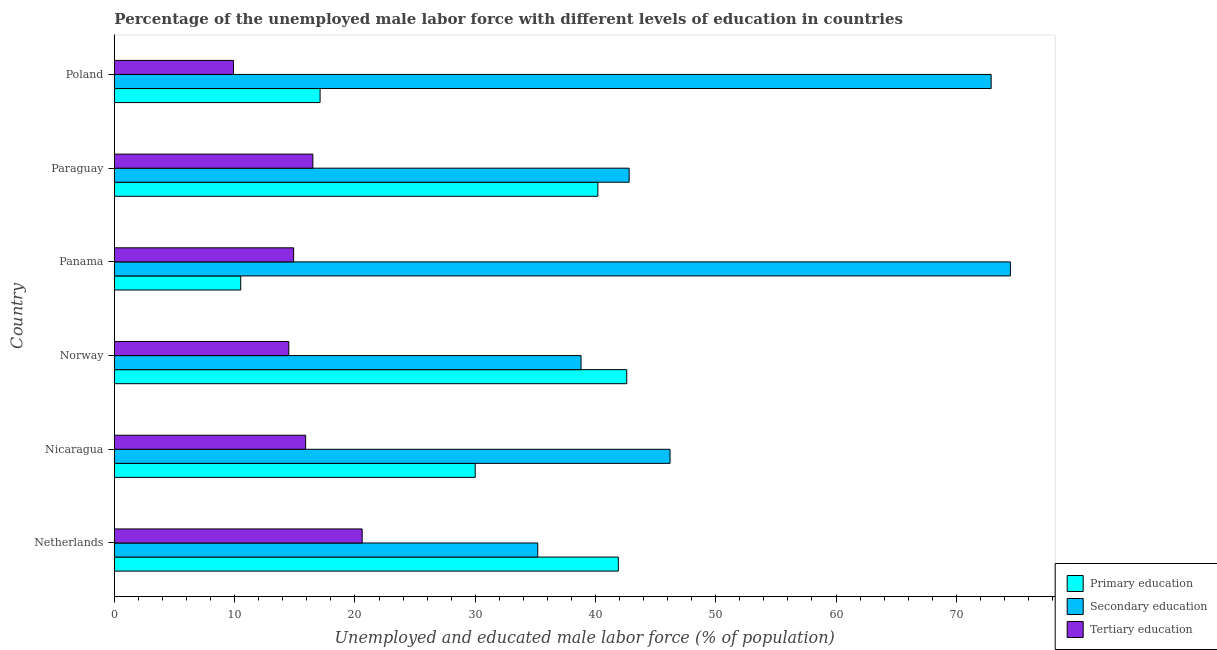How many different coloured bars are there?
Provide a succinct answer. 3. How many groups of bars are there?
Give a very brief answer. 6. Are the number of bars on each tick of the Y-axis equal?
Provide a succinct answer. Yes. How many bars are there on the 4th tick from the top?
Your answer should be compact. 3. In how many cases, is the number of bars for a given country not equal to the number of legend labels?
Offer a very short reply. 0. What is the percentage of male labor force who received secondary education in Norway?
Your answer should be compact. 38.8. Across all countries, what is the maximum percentage of male labor force who received tertiary education?
Your answer should be compact. 20.6. Across all countries, what is the minimum percentage of male labor force who received secondary education?
Give a very brief answer. 35.2. In which country was the percentage of male labor force who received secondary education maximum?
Offer a very short reply. Panama. In which country was the percentage of male labor force who received secondary education minimum?
Offer a terse response. Netherlands. What is the total percentage of male labor force who received tertiary education in the graph?
Ensure brevity in your answer.  92.3. What is the difference between the percentage of male labor force who received primary education in Paraguay and the percentage of male labor force who received tertiary education in Nicaragua?
Keep it short and to the point. 24.3. What is the average percentage of male labor force who received tertiary education per country?
Provide a succinct answer. 15.38. What is the difference between the percentage of male labor force who received primary education and percentage of male labor force who received secondary education in Nicaragua?
Your answer should be compact. -16.2. What is the ratio of the percentage of male labor force who received primary education in Nicaragua to that in Norway?
Ensure brevity in your answer.  0.7. Is the percentage of male labor force who received primary education in Norway less than that in Panama?
Make the answer very short. No. What is the difference between the highest and the lowest percentage of male labor force who received primary education?
Your answer should be very brief. 32.1. In how many countries, is the percentage of male labor force who received tertiary education greater than the average percentage of male labor force who received tertiary education taken over all countries?
Your answer should be compact. 3. Is the sum of the percentage of male labor force who received primary education in Nicaragua and Norway greater than the maximum percentage of male labor force who received tertiary education across all countries?
Offer a very short reply. Yes. What does the 1st bar from the bottom in Nicaragua represents?
Provide a succinct answer. Primary education. Is it the case that in every country, the sum of the percentage of male labor force who received primary education and percentage of male labor force who received secondary education is greater than the percentage of male labor force who received tertiary education?
Make the answer very short. Yes. How many bars are there?
Offer a terse response. 18. How many countries are there in the graph?
Offer a terse response. 6. Are the values on the major ticks of X-axis written in scientific E-notation?
Keep it short and to the point. No. Does the graph contain any zero values?
Ensure brevity in your answer.  No. Where does the legend appear in the graph?
Your response must be concise. Bottom right. What is the title of the graph?
Keep it short and to the point. Percentage of the unemployed male labor force with different levels of education in countries. What is the label or title of the X-axis?
Provide a short and direct response. Unemployed and educated male labor force (% of population). What is the label or title of the Y-axis?
Give a very brief answer. Country. What is the Unemployed and educated male labor force (% of population) in Primary education in Netherlands?
Your answer should be compact. 41.9. What is the Unemployed and educated male labor force (% of population) of Secondary education in Netherlands?
Make the answer very short. 35.2. What is the Unemployed and educated male labor force (% of population) in Tertiary education in Netherlands?
Provide a succinct answer. 20.6. What is the Unemployed and educated male labor force (% of population) in Secondary education in Nicaragua?
Offer a terse response. 46.2. What is the Unemployed and educated male labor force (% of population) of Tertiary education in Nicaragua?
Provide a short and direct response. 15.9. What is the Unemployed and educated male labor force (% of population) in Primary education in Norway?
Provide a short and direct response. 42.6. What is the Unemployed and educated male labor force (% of population) in Secondary education in Norway?
Your answer should be compact. 38.8. What is the Unemployed and educated male labor force (% of population) of Tertiary education in Norway?
Your answer should be very brief. 14.5. What is the Unemployed and educated male labor force (% of population) of Primary education in Panama?
Ensure brevity in your answer.  10.5. What is the Unemployed and educated male labor force (% of population) of Secondary education in Panama?
Your answer should be very brief. 74.5. What is the Unemployed and educated male labor force (% of population) in Tertiary education in Panama?
Your response must be concise. 14.9. What is the Unemployed and educated male labor force (% of population) in Primary education in Paraguay?
Offer a terse response. 40.2. What is the Unemployed and educated male labor force (% of population) in Secondary education in Paraguay?
Your answer should be very brief. 42.8. What is the Unemployed and educated male labor force (% of population) in Tertiary education in Paraguay?
Offer a terse response. 16.5. What is the Unemployed and educated male labor force (% of population) of Primary education in Poland?
Ensure brevity in your answer.  17.1. What is the Unemployed and educated male labor force (% of population) of Secondary education in Poland?
Your answer should be very brief. 72.9. What is the Unemployed and educated male labor force (% of population) in Tertiary education in Poland?
Offer a terse response. 9.9. Across all countries, what is the maximum Unemployed and educated male labor force (% of population) of Primary education?
Offer a terse response. 42.6. Across all countries, what is the maximum Unemployed and educated male labor force (% of population) in Secondary education?
Make the answer very short. 74.5. Across all countries, what is the maximum Unemployed and educated male labor force (% of population) of Tertiary education?
Provide a short and direct response. 20.6. Across all countries, what is the minimum Unemployed and educated male labor force (% of population) in Secondary education?
Ensure brevity in your answer.  35.2. Across all countries, what is the minimum Unemployed and educated male labor force (% of population) in Tertiary education?
Keep it short and to the point. 9.9. What is the total Unemployed and educated male labor force (% of population) in Primary education in the graph?
Offer a terse response. 182.3. What is the total Unemployed and educated male labor force (% of population) of Secondary education in the graph?
Ensure brevity in your answer.  310.4. What is the total Unemployed and educated male labor force (% of population) in Tertiary education in the graph?
Offer a terse response. 92.3. What is the difference between the Unemployed and educated male labor force (% of population) in Primary education in Netherlands and that in Nicaragua?
Make the answer very short. 11.9. What is the difference between the Unemployed and educated male labor force (% of population) in Secondary education in Netherlands and that in Norway?
Provide a succinct answer. -3.6. What is the difference between the Unemployed and educated male labor force (% of population) of Tertiary education in Netherlands and that in Norway?
Ensure brevity in your answer.  6.1. What is the difference between the Unemployed and educated male labor force (% of population) of Primary education in Netherlands and that in Panama?
Your response must be concise. 31.4. What is the difference between the Unemployed and educated male labor force (% of population) of Secondary education in Netherlands and that in Panama?
Your answer should be very brief. -39.3. What is the difference between the Unemployed and educated male labor force (% of population) of Primary education in Netherlands and that in Poland?
Make the answer very short. 24.8. What is the difference between the Unemployed and educated male labor force (% of population) in Secondary education in Netherlands and that in Poland?
Your answer should be very brief. -37.7. What is the difference between the Unemployed and educated male labor force (% of population) in Tertiary education in Netherlands and that in Poland?
Give a very brief answer. 10.7. What is the difference between the Unemployed and educated male labor force (% of population) of Secondary education in Nicaragua and that in Panama?
Ensure brevity in your answer.  -28.3. What is the difference between the Unemployed and educated male labor force (% of population) in Tertiary education in Nicaragua and that in Panama?
Your response must be concise. 1. What is the difference between the Unemployed and educated male labor force (% of population) in Primary education in Nicaragua and that in Paraguay?
Provide a succinct answer. -10.2. What is the difference between the Unemployed and educated male labor force (% of population) in Secondary education in Nicaragua and that in Paraguay?
Offer a very short reply. 3.4. What is the difference between the Unemployed and educated male labor force (% of population) in Tertiary education in Nicaragua and that in Paraguay?
Provide a succinct answer. -0.6. What is the difference between the Unemployed and educated male labor force (% of population) in Secondary education in Nicaragua and that in Poland?
Keep it short and to the point. -26.7. What is the difference between the Unemployed and educated male labor force (% of population) in Tertiary education in Nicaragua and that in Poland?
Ensure brevity in your answer.  6. What is the difference between the Unemployed and educated male labor force (% of population) in Primary education in Norway and that in Panama?
Provide a succinct answer. 32.1. What is the difference between the Unemployed and educated male labor force (% of population) of Secondary education in Norway and that in Panama?
Provide a succinct answer. -35.7. What is the difference between the Unemployed and educated male labor force (% of population) of Secondary education in Norway and that in Paraguay?
Keep it short and to the point. -4. What is the difference between the Unemployed and educated male labor force (% of population) of Secondary education in Norway and that in Poland?
Provide a succinct answer. -34.1. What is the difference between the Unemployed and educated male labor force (% of population) of Tertiary education in Norway and that in Poland?
Keep it short and to the point. 4.6. What is the difference between the Unemployed and educated male labor force (% of population) in Primary education in Panama and that in Paraguay?
Your answer should be compact. -29.7. What is the difference between the Unemployed and educated male labor force (% of population) in Secondary education in Panama and that in Paraguay?
Offer a terse response. 31.7. What is the difference between the Unemployed and educated male labor force (% of population) in Tertiary education in Panama and that in Paraguay?
Your response must be concise. -1.6. What is the difference between the Unemployed and educated male labor force (% of population) in Tertiary education in Panama and that in Poland?
Make the answer very short. 5. What is the difference between the Unemployed and educated male labor force (% of population) of Primary education in Paraguay and that in Poland?
Provide a short and direct response. 23.1. What is the difference between the Unemployed and educated male labor force (% of population) in Secondary education in Paraguay and that in Poland?
Your response must be concise. -30.1. What is the difference between the Unemployed and educated male labor force (% of population) of Tertiary education in Paraguay and that in Poland?
Give a very brief answer. 6.6. What is the difference between the Unemployed and educated male labor force (% of population) in Primary education in Netherlands and the Unemployed and educated male labor force (% of population) in Tertiary education in Nicaragua?
Give a very brief answer. 26. What is the difference between the Unemployed and educated male labor force (% of population) in Secondary education in Netherlands and the Unemployed and educated male labor force (% of population) in Tertiary education in Nicaragua?
Your response must be concise. 19.3. What is the difference between the Unemployed and educated male labor force (% of population) in Primary education in Netherlands and the Unemployed and educated male labor force (% of population) in Secondary education in Norway?
Ensure brevity in your answer.  3.1. What is the difference between the Unemployed and educated male labor force (% of population) of Primary education in Netherlands and the Unemployed and educated male labor force (% of population) of Tertiary education in Norway?
Give a very brief answer. 27.4. What is the difference between the Unemployed and educated male labor force (% of population) in Secondary education in Netherlands and the Unemployed and educated male labor force (% of population) in Tertiary education in Norway?
Offer a terse response. 20.7. What is the difference between the Unemployed and educated male labor force (% of population) in Primary education in Netherlands and the Unemployed and educated male labor force (% of population) in Secondary education in Panama?
Ensure brevity in your answer.  -32.6. What is the difference between the Unemployed and educated male labor force (% of population) of Secondary education in Netherlands and the Unemployed and educated male labor force (% of population) of Tertiary education in Panama?
Offer a very short reply. 20.3. What is the difference between the Unemployed and educated male labor force (% of population) in Primary education in Netherlands and the Unemployed and educated male labor force (% of population) in Tertiary education in Paraguay?
Give a very brief answer. 25.4. What is the difference between the Unemployed and educated male labor force (% of population) of Primary education in Netherlands and the Unemployed and educated male labor force (% of population) of Secondary education in Poland?
Provide a succinct answer. -31. What is the difference between the Unemployed and educated male labor force (% of population) of Secondary education in Netherlands and the Unemployed and educated male labor force (% of population) of Tertiary education in Poland?
Make the answer very short. 25.3. What is the difference between the Unemployed and educated male labor force (% of population) in Primary education in Nicaragua and the Unemployed and educated male labor force (% of population) in Secondary education in Norway?
Keep it short and to the point. -8.8. What is the difference between the Unemployed and educated male labor force (% of population) in Secondary education in Nicaragua and the Unemployed and educated male labor force (% of population) in Tertiary education in Norway?
Keep it short and to the point. 31.7. What is the difference between the Unemployed and educated male labor force (% of population) of Primary education in Nicaragua and the Unemployed and educated male labor force (% of population) of Secondary education in Panama?
Your answer should be compact. -44.5. What is the difference between the Unemployed and educated male labor force (% of population) in Secondary education in Nicaragua and the Unemployed and educated male labor force (% of population) in Tertiary education in Panama?
Provide a short and direct response. 31.3. What is the difference between the Unemployed and educated male labor force (% of population) in Primary education in Nicaragua and the Unemployed and educated male labor force (% of population) in Secondary education in Paraguay?
Your answer should be very brief. -12.8. What is the difference between the Unemployed and educated male labor force (% of population) of Secondary education in Nicaragua and the Unemployed and educated male labor force (% of population) of Tertiary education in Paraguay?
Offer a very short reply. 29.7. What is the difference between the Unemployed and educated male labor force (% of population) of Primary education in Nicaragua and the Unemployed and educated male labor force (% of population) of Secondary education in Poland?
Your answer should be compact. -42.9. What is the difference between the Unemployed and educated male labor force (% of population) of Primary education in Nicaragua and the Unemployed and educated male labor force (% of population) of Tertiary education in Poland?
Keep it short and to the point. 20.1. What is the difference between the Unemployed and educated male labor force (% of population) of Secondary education in Nicaragua and the Unemployed and educated male labor force (% of population) of Tertiary education in Poland?
Offer a very short reply. 36.3. What is the difference between the Unemployed and educated male labor force (% of population) in Primary education in Norway and the Unemployed and educated male labor force (% of population) in Secondary education in Panama?
Provide a short and direct response. -31.9. What is the difference between the Unemployed and educated male labor force (% of population) in Primary education in Norway and the Unemployed and educated male labor force (% of population) in Tertiary education in Panama?
Give a very brief answer. 27.7. What is the difference between the Unemployed and educated male labor force (% of population) in Secondary education in Norway and the Unemployed and educated male labor force (% of population) in Tertiary education in Panama?
Give a very brief answer. 23.9. What is the difference between the Unemployed and educated male labor force (% of population) of Primary education in Norway and the Unemployed and educated male labor force (% of population) of Secondary education in Paraguay?
Offer a very short reply. -0.2. What is the difference between the Unemployed and educated male labor force (% of population) of Primary education in Norway and the Unemployed and educated male labor force (% of population) of Tertiary education in Paraguay?
Ensure brevity in your answer.  26.1. What is the difference between the Unemployed and educated male labor force (% of population) in Secondary education in Norway and the Unemployed and educated male labor force (% of population) in Tertiary education in Paraguay?
Provide a succinct answer. 22.3. What is the difference between the Unemployed and educated male labor force (% of population) in Primary education in Norway and the Unemployed and educated male labor force (% of population) in Secondary education in Poland?
Provide a succinct answer. -30.3. What is the difference between the Unemployed and educated male labor force (% of population) in Primary education in Norway and the Unemployed and educated male labor force (% of population) in Tertiary education in Poland?
Provide a short and direct response. 32.7. What is the difference between the Unemployed and educated male labor force (% of population) of Secondary education in Norway and the Unemployed and educated male labor force (% of population) of Tertiary education in Poland?
Make the answer very short. 28.9. What is the difference between the Unemployed and educated male labor force (% of population) of Primary education in Panama and the Unemployed and educated male labor force (% of population) of Secondary education in Paraguay?
Offer a terse response. -32.3. What is the difference between the Unemployed and educated male labor force (% of population) in Primary education in Panama and the Unemployed and educated male labor force (% of population) in Tertiary education in Paraguay?
Your response must be concise. -6. What is the difference between the Unemployed and educated male labor force (% of population) in Secondary education in Panama and the Unemployed and educated male labor force (% of population) in Tertiary education in Paraguay?
Offer a terse response. 58. What is the difference between the Unemployed and educated male labor force (% of population) of Primary education in Panama and the Unemployed and educated male labor force (% of population) of Secondary education in Poland?
Your answer should be compact. -62.4. What is the difference between the Unemployed and educated male labor force (% of population) of Primary education in Panama and the Unemployed and educated male labor force (% of population) of Tertiary education in Poland?
Offer a very short reply. 0.6. What is the difference between the Unemployed and educated male labor force (% of population) of Secondary education in Panama and the Unemployed and educated male labor force (% of population) of Tertiary education in Poland?
Keep it short and to the point. 64.6. What is the difference between the Unemployed and educated male labor force (% of population) of Primary education in Paraguay and the Unemployed and educated male labor force (% of population) of Secondary education in Poland?
Offer a terse response. -32.7. What is the difference between the Unemployed and educated male labor force (% of population) in Primary education in Paraguay and the Unemployed and educated male labor force (% of population) in Tertiary education in Poland?
Your answer should be very brief. 30.3. What is the difference between the Unemployed and educated male labor force (% of population) of Secondary education in Paraguay and the Unemployed and educated male labor force (% of population) of Tertiary education in Poland?
Make the answer very short. 32.9. What is the average Unemployed and educated male labor force (% of population) of Primary education per country?
Keep it short and to the point. 30.38. What is the average Unemployed and educated male labor force (% of population) of Secondary education per country?
Provide a succinct answer. 51.73. What is the average Unemployed and educated male labor force (% of population) of Tertiary education per country?
Make the answer very short. 15.38. What is the difference between the Unemployed and educated male labor force (% of population) in Primary education and Unemployed and educated male labor force (% of population) in Secondary education in Netherlands?
Keep it short and to the point. 6.7. What is the difference between the Unemployed and educated male labor force (% of population) of Primary education and Unemployed and educated male labor force (% of population) of Tertiary education in Netherlands?
Give a very brief answer. 21.3. What is the difference between the Unemployed and educated male labor force (% of population) of Secondary education and Unemployed and educated male labor force (% of population) of Tertiary education in Netherlands?
Provide a succinct answer. 14.6. What is the difference between the Unemployed and educated male labor force (% of population) of Primary education and Unemployed and educated male labor force (% of population) of Secondary education in Nicaragua?
Offer a terse response. -16.2. What is the difference between the Unemployed and educated male labor force (% of population) of Secondary education and Unemployed and educated male labor force (% of population) of Tertiary education in Nicaragua?
Give a very brief answer. 30.3. What is the difference between the Unemployed and educated male labor force (% of population) of Primary education and Unemployed and educated male labor force (% of population) of Secondary education in Norway?
Offer a terse response. 3.8. What is the difference between the Unemployed and educated male labor force (% of population) of Primary education and Unemployed and educated male labor force (% of population) of Tertiary education in Norway?
Give a very brief answer. 28.1. What is the difference between the Unemployed and educated male labor force (% of population) in Secondary education and Unemployed and educated male labor force (% of population) in Tertiary education in Norway?
Offer a terse response. 24.3. What is the difference between the Unemployed and educated male labor force (% of population) in Primary education and Unemployed and educated male labor force (% of population) in Secondary education in Panama?
Make the answer very short. -64. What is the difference between the Unemployed and educated male labor force (% of population) of Primary education and Unemployed and educated male labor force (% of population) of Tertiary education in Panama?
Provide a succinct answer. -4.4. What is the difference between the Unemployed and educated male labor force (% of population) in Secondary education and Unemployed and educated male labor force (% of population) in Tertiary education in Panama?
Offer a terse response. 59.6. What is the difference between the Unemployed and educated male labor force (% of population) of Primary education and Unemployed and educated male labor force (% of population) of Tertiary education in Paraguay?
Provide a succinct answer. 23.7. What is the difference between the Unemployed and educated male labor force (% of population) of Secondary education and Unemployed and educated male labor force (% of population) of Tertiary education in Paraguay?
Offer a very short reply. 26.3. What is the difference between the Unemployed and educated male labor force (% of population) in Primary education and Unemployed and educated male labor force (% of population) in Secondary education in Poland?
Provide a succinct answer. -55.8. What is the difference between the Unemployed and educated male labor force (% of population) of Secondary education and Unemployed and educated male labor force (% of population) of Tertiary education in Poland?
Your answer should be compact. 63. What is the ratio of the Unemployed and educated male labor force (% of population) in Primary education in Netherlands to that in Nicaragua?
Provide a succinct answer. 1.4. What is the ratio of the Unemployed and educated male labor force (% of population) in Secondary education in Netherlands to that in Nicaragua?
Make the answer very short. 0.76. What is the ratio of the Unemployed and educated male labor force (% of population) of Tertiary education in Netherlands to that in Nicaragua?
Your response must be concise. 1.3. What is the ratio of the Unemployed and educated male labor force (% of population) of Primary education in Netherlands to that in Norway?
Your answer should be compact. 0.98. What is the ratio of the Unemployed and educated male labor force (% of population) in Secondary education in Netherlands to that in Norway?
Make the answer very short. 0.91. What is the ratio of the Unemployed and educated male labor force (% of population) in Tertiary education in Netherlands to that in Norway?
Provide a succinct answer. 1.42. What is the ratio of the Unemployed and educated male labor force (% of population) of Primary education in Netherlands to that in Panama?
Give a very brief answer. 3.99. What is the ratio of the Unemployed and educated male labor force (% of population) in Secondary education in Netherlands to that in Panama?
Make the answer very short. 0.47. What is the ratio of the Unemployed and educated male labor force (% of population) of Tertiary education in Netherlands to that in Panama?
Keep it short and to the point. 1.38. What is the ratio of the Unemployed and educated male labor force (% of population) of Primary education in Netherlands to that in Paraguay?
Your response must be concise. 1.04. What is the ratio of the Unemployed and educated male labor force (% of population) in Secondary education in Netherlands to that in Paraguay?
Provide a succinct answer. 0.82. What is the ratio of the Unemployed and educated male labor force (% of population) of Tertiary education in Netherlands to that in Paraguay?
Your answer should be very brief. 1.25. What is the ratio of the Unemployed and educated male labor force (% of population) in Primary education in Netherlands to that in Poland?
Your answer should be compact. 2.45. What is the ratio of the Unemployed and educated male labor force (% of population) of Secondary education in Netherlands to that in Poland?
Provide a short and direct response. 0.48. What is the ratio of the Unemployed and educated male labor force (% of population) in Tertiary education in Netherlands to that in Poland?
Your answer should be very brief. 2.08. What is the ratio of the Unemployed and educated male labor force (% of population) of Primary education in Nicaragua to that in Norway?
Provide a short and direct response. 0.7. What is the ratio of the Unemployed and educated male labor force (% of population) of Secondary education in Nicaragua to that in Norway?
Your answer should be compact. 1.19. What is the ratio of the Unemployed and educated male labor force (% of population) in Tertiary education in Nicaragua to that in Norway?
Keep it short and to the point. 1.1. What is the ratio of the Unemployed and educated male labor force (% of population) in Primary education in Nicaragua to that in Panama?
Offer a terse response. 2.86. What is the ratio of the Unemployed and educated male labor force (% of population) of Secondary education in Nicaragua to that in Panama?
Your answer should be very brief. 0.62. What is the ratio of the Unemployed and educated male labor force (% of population) in Tertiary education in Nicaragua to that in Panama?
Provide a short and direct response. 1.07. What is the ratio of the Unemployed and educated male labor force (% of population) of Primary education in Nicaragua to that in Paraguay?
Give a very brief answer. 0.75. What is the ratio of the Unemployed and educated male labor force (% of population) of Secondary education in Nicaragua to that in Paraguay?
Give a very brief answer. 1.08. What is the ratio of the Unemployed and educated male labor force (% of population) of Tertiary education in Nicaragua to that in Paraguay?
Keep it short and to the point. 0.96. What is the ratio of the Unemployed and educated male labor force (% of population) of Primary education in Nicaragua to that in Poland?
Keep it short and to the point. 1.75. What is the ratio of the Unemployed and educated male labor force (% of population) of Secondary education in Nicaragua to that in Poland?
Give a very brief answer. 0.63. What is the ratio of the Unemployed and educated male labor force (% of population) of Tertiary education in Nicaragua to that in Poland?
Offer a terse response. 1.61. What is the ratio of the Unemployed and educated male labor force (% of population) of Primary education in Norway to that in Panama?
Offer a very short reply. 4.06. What is the ratio of the Unemployed and educated male labor force (% of population) of Secondary education in Norway to that in Panama?
Offer a terse response. 0.52. What is the ratio of the Unemployed and educated male labor force (% of population) in Tertiary education in Norway to that in Panama?
Give a very brief answer. 0.97. What is the ratio of the Unemployed and educated male labor force (% of population) in Primary education in Norway to that in Paraguay?
Your response must be concise. 1.06. What is the ratio of the Unemployed and educated male labor force (% of population) of Secondary education in Norway to that in Paraguay?
Your response must be concise. 0.91. What is the ratio of the Unemployed and educated male labor force (% of population) in Tertiary education in Norway to that in Paraguay?
Your answer should be compact. 0.88. What is the ratio of the Unemployed and educated male labor force (% of population) of Primary education in Norway to that in Poland?
Give a very brief answer. 2.49. What is the ratio of the Unemployed and educated male labor force (% of population) of Secondary education in Norway to that in Poland?
Keep it short and to the point. 0.53. What is the ratio of the Unemployed and educated male labor force (% of population) in Tertiary education in Norway to that in Poland?
Offer a terse response. 1.46. What is the ratio of the Unemployed and educated male labor force (% of population) of Primary education in Panama to that in Paraguay?
Keep it short and to the point. 0.26. What is the ratio of the Unemployed and educated male labor force (% of population) of Secondary education in Panama to that in Paraguay?
Offer a very short reply. 1.74. What is the ratio of the Unemployed and educated male labor force (% of population) of Tertiary education in Panama to that in Paraguay?
Offer a terse response. 0.9. What is the ratio of the Unemployed and educated male labor force (% of population) in Primary education in Panama to that in Poland?
Your response must be concise. 0.61. What is the ratio of the Unemployed and educated male labor force (% of population) of Secondary education in Panama to that in Poland?
Offer a very short reply. 1.02. What is the ratio of the Unemployed and educated male labor force (% of population) of Tertiary education in Panama to that in Poland?
Offer a very short reply. 1.51. What is the ratio of the Unemployed and educated male labor force (% of population) of Primary education in Paraguay to that in Poland?
Ensure brevity in your answer.  2.35. What is the ratio of the Unemployed and educated male labor force (% of population) in Secondary education in Paraguay to that in Poland?
Offer a terse response. 0.59. What is the ratio of the Unemployed and educated male labor force (% of population) in Tertiary education in Paraguay to that in Poland?
Your response must be concise. 1.67. What is the difference between the highest and the second highest Unemployed and educated male labor force (% of population) of Secondary education?
Offer a very short reply. 1.6. What is the difference between the highest and the second highest Unemployed and educated male labor force (% of population) of Tertiary education?
Offer a terse response. 4.1. What is the difference between the highest and the lowest Unemployed and educated male labor force (% of population) in Primary education?
Offer a very short reply. 32.1. What is the difference between the highest and the lowest Unemployed and educated male labor force (% of population) of Secondary education?
Provide a succinct answer. 39.3. What is the difference between the highest and the lowest Unemployed and educated male labor force (% of population) of Tertiary education?
Your response must be concise. 10.7. 